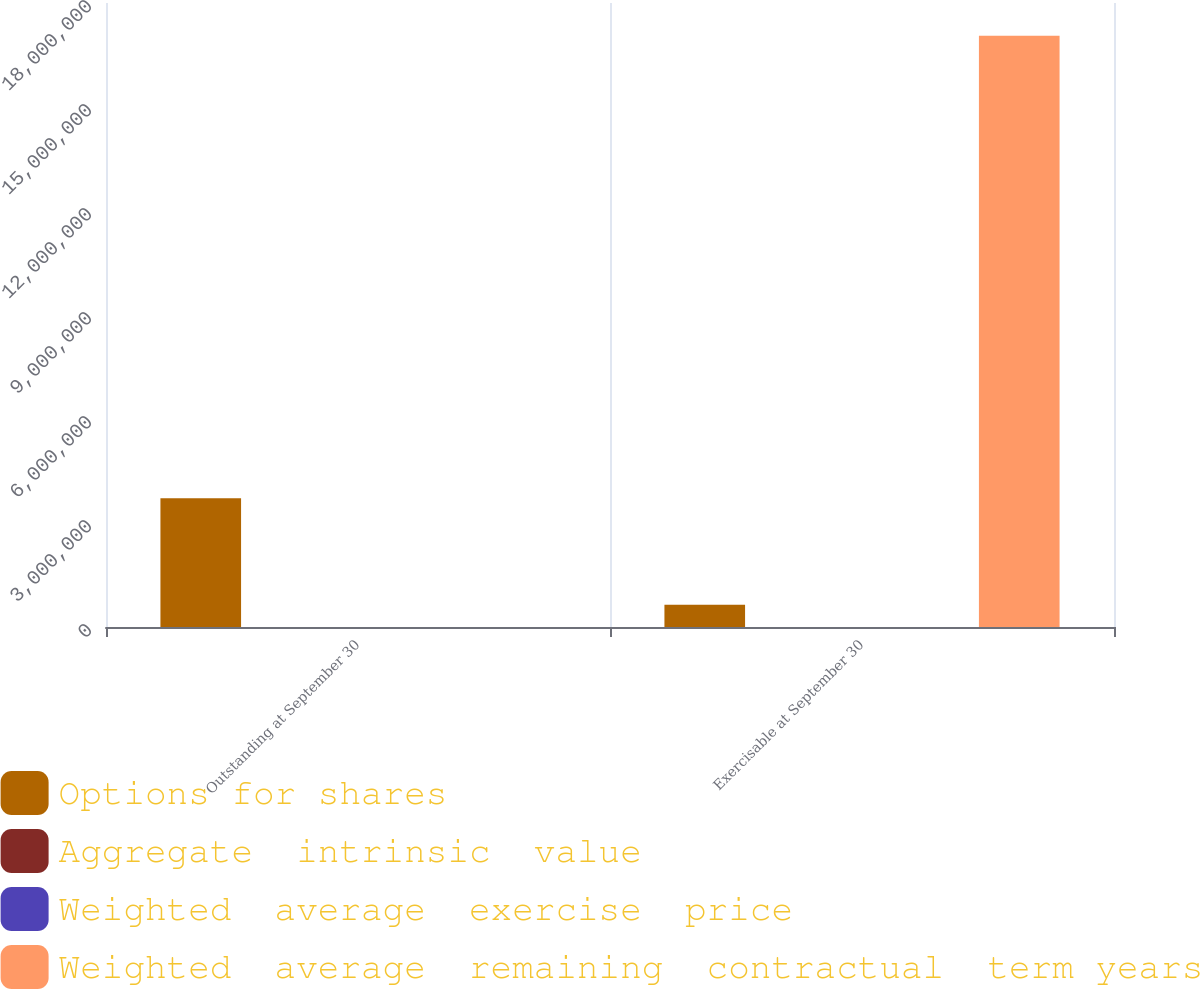<chart> <loc_0><loc_0><loc_500><loc_500><stacked_bar_chart><ecel><fcel>Outstanding at September 30<fcel>Exercisable at September 30<nl><fcel>Options for shares<fcel>3.71047e+06<fcel>639607<nl><fcel>Aggregate  intrinsic  value<fcel>44.88<fcel>31.54<nl><fcel>Weighted  average  exercise  price<fcel>3.5<fcel>1.35<nl><fcel>Weighted  average  remaining  contractual  term years<fcel>44.88<fcel>1.7058e+07<nl></chart> 